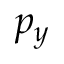Convert formula to latex. <formula><loc_0><loc_0><loc_500><loc_500>p _ { y }</formula> 